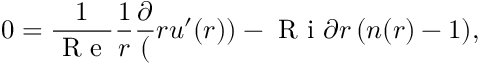<formula> <loc_0><loc_0><loc_500><loc_500>0 = \frac { 1 } { R e } \frac { 1 } { r } \frac { \partial } ( r u ^ { \prime } ( r ) ) - R i { \partial r } \, ( n ( r ) - 1 ) ,</formula> 